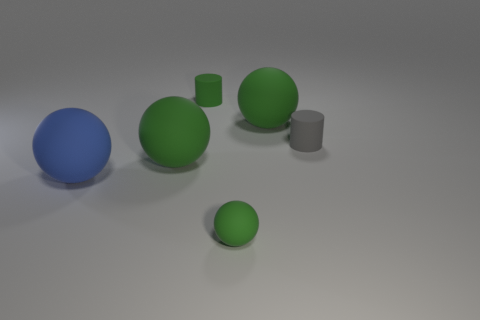How many other big blue matte things have the same shape as the big blue matte thing?
Your answer should be very brief. 0. There is a rubber object that is to the left of the small matte ball and behind the small gray cylinder; what is its color?
Make the answer very short. Green. What number of tiny blue balls are there?
Ensure brevity in your answer.  0. Does the blue sphere have the same size as the gray cylinder?
Provide a short and direct response. No. Is there a big rubber object of the same color as the tiny rubber ball?
Keep it short and to the point. Yes. There is a small green thing in front of the large blue rubber object; does it have the same shape as the blue object?
Make the answer very short. Yes. How many other green matte cylinders have the same size as the green cylinder?
Offer a very short reply. 0. How many tiny green matte things are to the left of the object that is in front of the large blue matte ball?
Offer a very short reply. 1. Is the material of the thing that is in front of the big blue sphere the same as the green object that is on the right side of the tiny green sphere?
Give a very brief answer. Yes. Is the number of green balls behind the tiny green matte sphere greater than the number of big blue rubber objects?
Provide a succinct answer. Yes. 